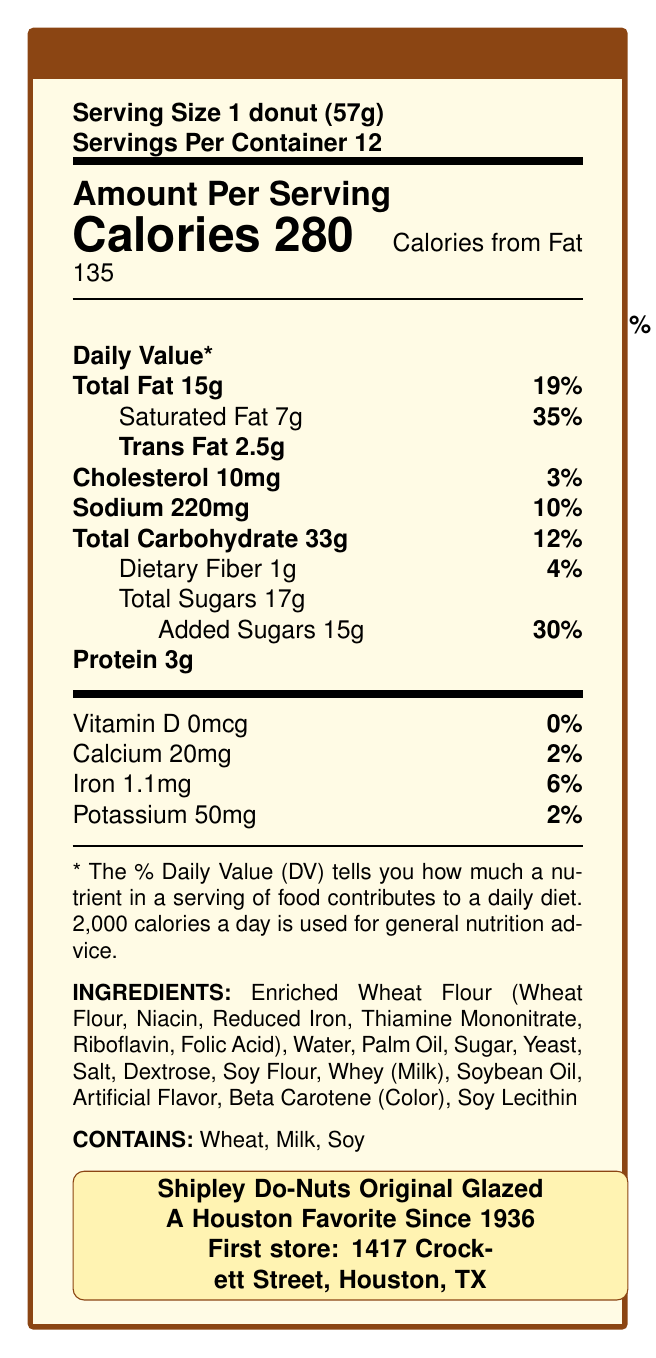How many grams of trans fat are in one Shipley Do-Nut? The document states "Trans Fat 2.5g".
Answer: 2.5g How much sugar does one donut contain? Under "Total Sugars", it mentions "17g".
Answer: 17g What percentage of the daily value is the added sugars per serving? It is listed as "Added Sugars 15g 30%".
Answer: 30% How many calories come from fat in one donut? The document displays "Calories from Fat 135".
Answer: 135 What are the allergens listed on the Nutrition Facts Label? The provided allergens section lists "Wheat, Milk, Soy".
Answer: Wheat, Milk, Soy What is the % Daily Value of saturated fat in one serving? A. 10% B. 20% C. 35% D. 40% The document mentions "Saturated Fat 7g 35%".
Answer: C. 35% Which brand's donuts have a higher trans fat content than Shipley Do-Nuts? A. Krispy Kreme B. Dunkin' Donuts C. Tim Hortons D. Starbucks The competitor comparison indicates "50% higher than Krispy Kreme".
Answer: A. Krispy Kreme Is the calcium content in one donut more than 5% of the daily value? The document lists "Calcium 20mg 2%".
Answer: No Summarize the main idea of the document. The main idea of the document is to provide nutritional information of Shipley Do-Nuts, including total fats, trans fats, sugars, protein, and a nostalgic branding affiliated with Houston.
Answer: The document outlines the Nutrition Facts Label for a dozen Shipley Do-Nuts, detailing serving size, calories, fat content, sugar content, allergens, ingredients, and a nostalgic note about its Houston heritage. Can we determine the fiber content in a dozen donuts based on the visual information? The fiber content per donut is listed as 1g, and since there are 12 donuts in the box, you can multiply to find the total fiber content.
Answer: Yes Is Shipley Do-Nuts a Houston favorite since 1936? The document includes "A Houston Favorite Since 1936".
Answer: Yes Does the document provide the first street address of Shipley Do-Nuts? It states "First store: 1417 Crockett Street, Houston, TX".
Answer: Yes What is the nostalgic flavor mentioned in the document? The document refers to "nostalgic flavor: Classic Glazed".
Answer: Classic Glazed Can we determine the average amount of calories in a dozen donuts from this document? By multiplying the calories per donut (280) by the number of donuts (12), we get the total calories (3360).
Answer: Yes Are any vitamins other than Vitamin D listed in the nutritional information? The document lists Vitamin D specifically but does not mention any other vitamins.
Answer: No 